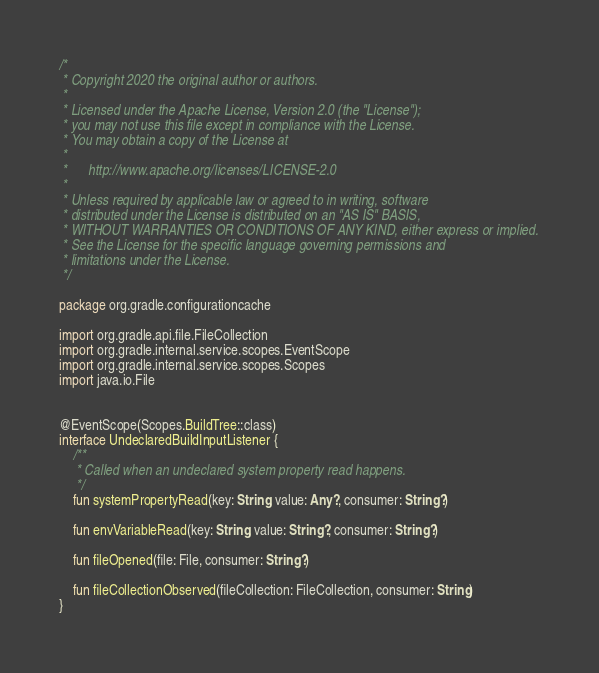<code> <loc_0><loc_0><loc_500><loc_500><_Kotlin_>/*
 * Copyright 2020 the original author or authors.
 *
 * Licensed under the Apache License, Version 2.0 (the "License");
 * you may not use this file except in compliance with the License.
 * You may obtain a copy of the License at
 *
 *      http://www.apache.org/licenses/LICENSE-2.0
 *
 * Unless required by applicable law or agreed to in writing, software
 * distributed under the License is distributed on an "AS IS" BASIS,
 * WITHOUT WARRANTIES OR CONDITIONS OF ANY KIND, either express or implied.
 * See the License for the specific language governing permissions and
 * limitations under the License.
 */

package org.gradle.configurationcache

import org.gradle.api.file.FileCollection
import org.gradle.internal.service.scopes.EventScope
import org.gradle.internal.service.scopes.Scopes
import java.io.File


@EventScope(Scopes.BuildTree::class)
interface UndeclaredBuildInputListener {
    /**
     * Called when an undeclared system property read happens.
     */
    fun systemPropertyRead(key: String, value: Any?, consumer: String?)

    fun envVariableRead(key: String, value: String?, consumer: String?)

    fun fileOpened(file: File, consumer: String?)

    fun fileCollectionObserved(fileCollection: FileCollection, consumer: String)
}
</code> 